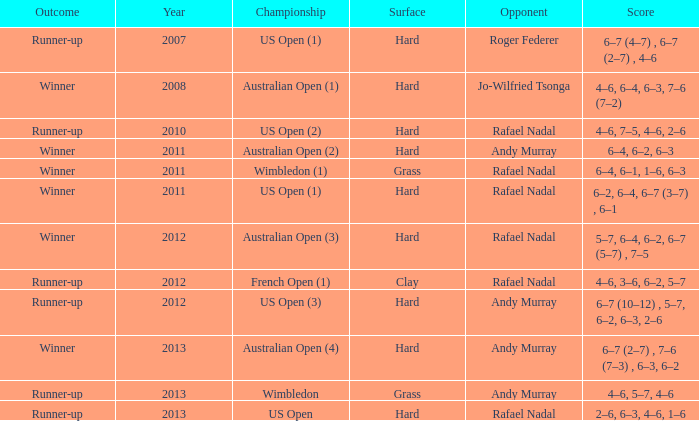On what surface was the australian open (1) conducted? Hard. 